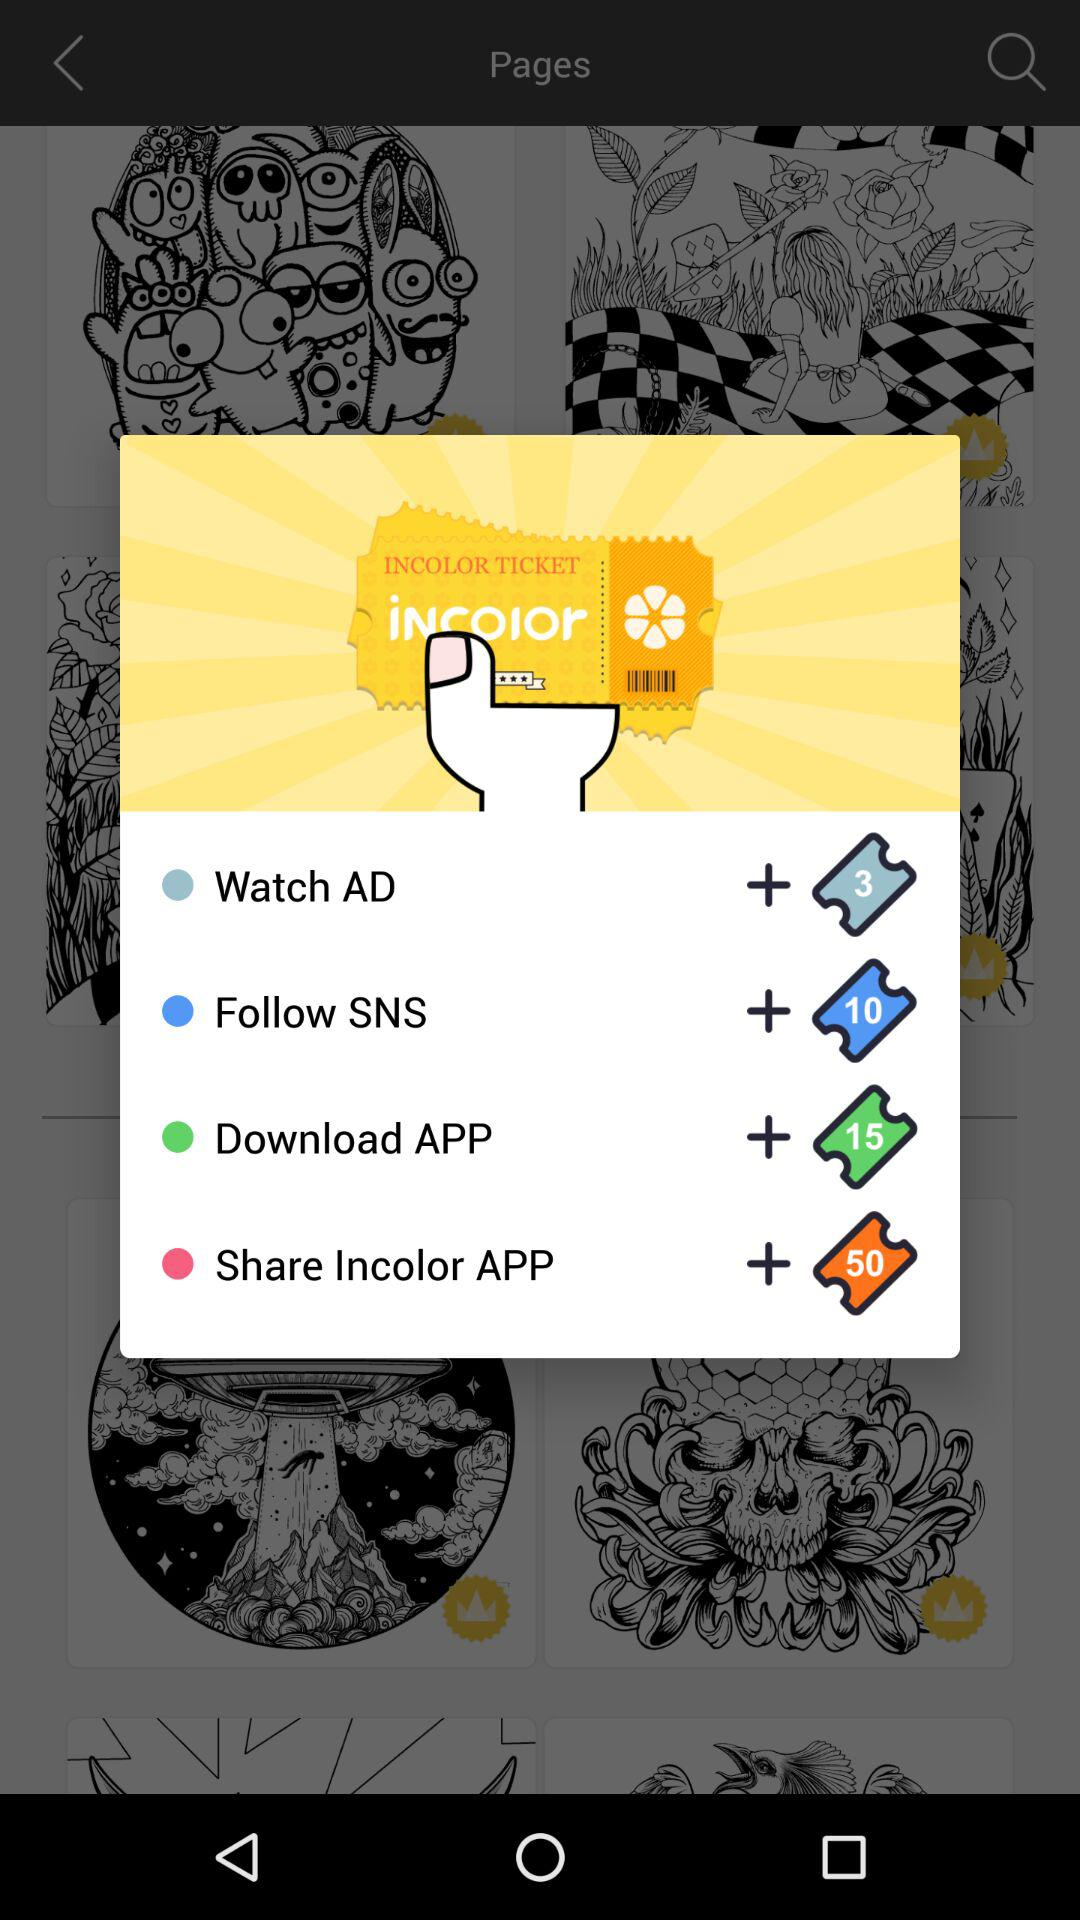How many points are needed to redeem the biggest reward?
Answer the question using a single word or phrase. 50 